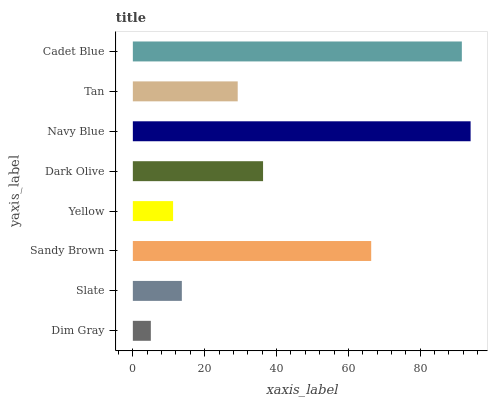Is Dim Gray the minimum?
Answer yes or no. Yes. Is Navy Blue the maximum?
Answer yes or no. Yes. Is Slate the minimum?
Answer yes or no. No. Is Slate the maximum?
Answer yes or no. No. Is Slate greater than Dim Gray?
Answer yes or no. Yes. Is Dim Gray less than Slate?
Answer yes or no. Yes. Is Dim Gray greater than Slate?
Answer yes or no. No. Is Slate less than Dim Gray?
Answer yes or no. No. Is Dark Olive the high median?
Answer yes or no. Yes. Is Tan the low median?
Answer yes or no. Yes. Is Yellow the high median?
Answer yes or no. No. Is Slate the low median?
Answer yes or no. No. 